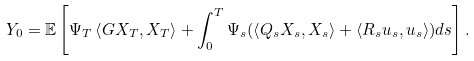<formula> <loc_0><loc_0><loc_500><loc_500>Y _ { 0 } = \mathbb { E } \left [ \Psi _ { T } \left \langle G X _ { T } , X _ { T } \right \rangle + \int _ { 0 } ^ { T } \Psi _ { s } ( \left \langle Q _ { s } X _ { s } , X _ { s } \right \rangle + \left \langle R _ { s } u _ { s } , u _ { s } \right \rangle ) d s \right ] .</formula> 